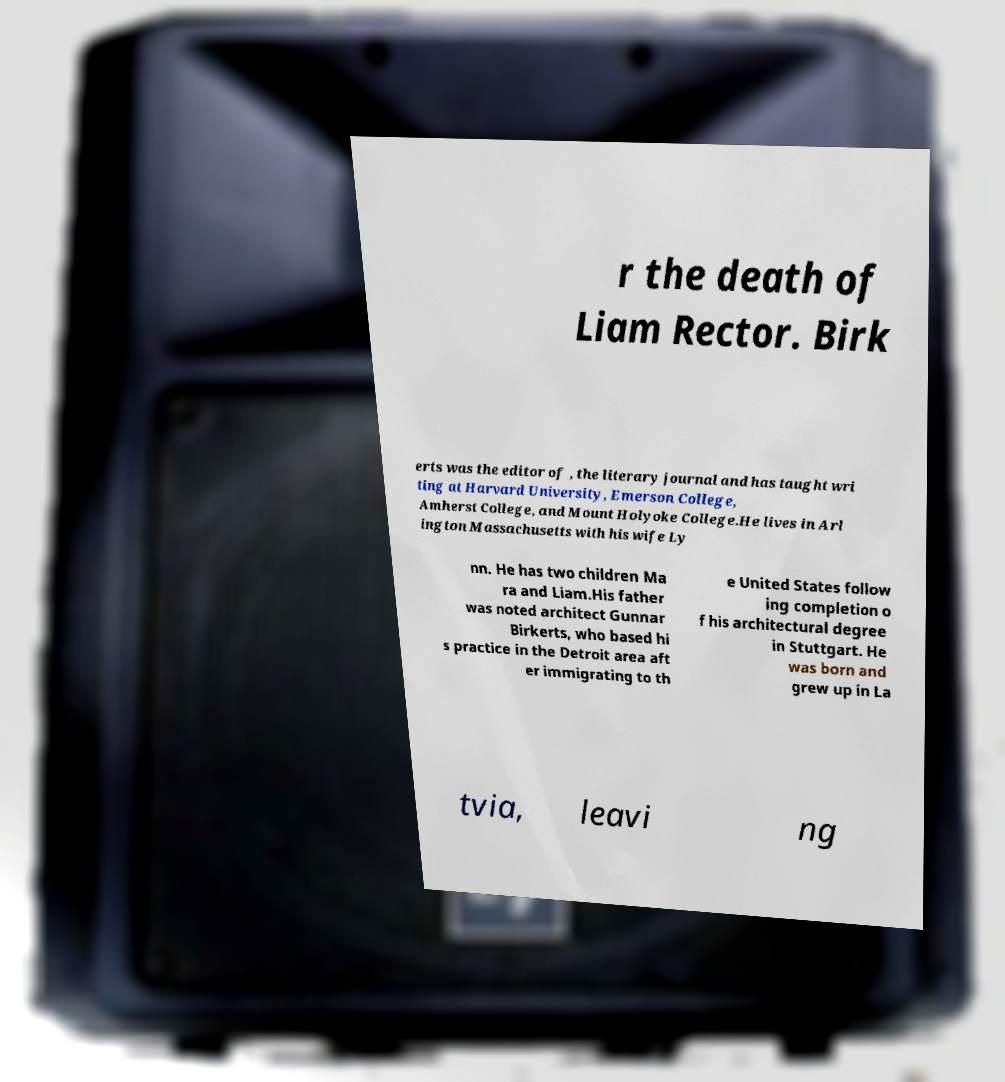Please identify and transcribe the text found in this image. r the death of Liam Rector. Birk erts was the editor of , the literary journal and has taught wri ting at Harvard University, Emerson College, Amherst College, and Mount Holyoke College.He lives in Arl ington Massachusetts with his wife Ly nn. He has two children Ma ra and Liam.His father was noted architect Gunnar Birkerts, who based hi s practice in the Detroit area aft er immigrating to th e United States follow ing completion o f his architectural degree in Stuttgart. He was born and grew up in La tvia, leavi ng 